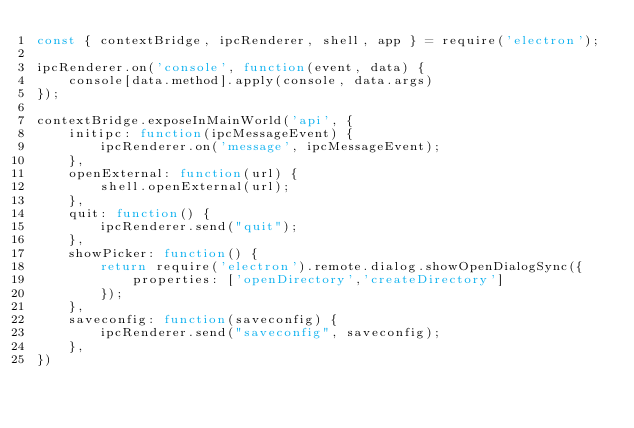Convert code to text. <code><loc_0><loc_0><loc_500><loc_500><_JavaScript_>const { contextBridge, ipcRenderer, shell, app } = require('electron');

ipcRenderer.on('console', function(event, data) {
	console[data.method].apply(console, data.args)
});

contextBridge.exposeInMainWorld('api', {
    initipc: function(ipcMessageEvent) {
        ipcRenderer.on('message', ipcMessageEvent);
    },
    openExternal: function(url) {
        shell.openExternal(url);
    },
    quit: function() {
        ipcRenderer.send("quit");
    },
    showPicker: function() {
        return require('electron').remote.dialog.showOpenDialogSync({
            properties: ['openDirectory','createDirectory']
        });
    },
    saveconfig: function(saveconfig) {
        ipcRenderer.send("saveconfig", saveconfig);
    },
})</code> 